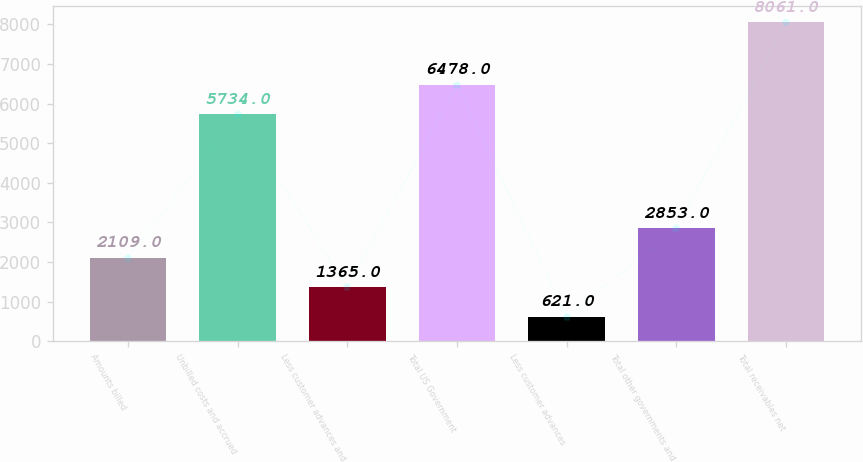Convert chart. <chart><loc_0><loc_0><loc_500><loc_500><bar_chart><fcel>Amounts billed<fcel>Unbilled costs and accrued<fcel>Less customer advances and<fcel>Total US Government<fcel>Less customer advances<fcel>Total other governments and<fcel>Total receivables net<nl><fcel>2109<fcel>5734<fcel>1365<fcel>6478<fcel>621<fcel>2853<fcel>8061<nl></chart> 